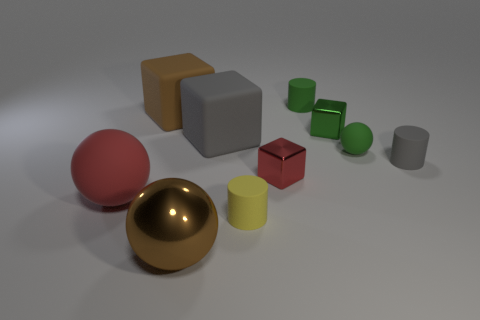Are there an equal number of tiny green shiny things that are right of the tiny red metallic block and tiny green metal things on the left side of the tiny green metal block?
Your answer should be very brief. No. What is the color of the other small thing that is the same shape as the tiny green metallic object?
Your response must be concise. Red. Are there any other things that are the same color as the metal sphere?
Offer a terse response. Yes. What number of matte things are tiny green objects or gray cylinders?
Your answer should be compact. 3. Is the color of the metal ball the same as the tiny rubber sphere?
Your answer should be very brief. No. Are there more small gray rubber cylinders right of the tiny green block than tiny red spheres?
Your answer should be compact. Yes. How many other objects are the same material as the large brown ball?
Keep it short and to the point. 2. What number of large things are red rubber objects or metal balls?
Ensure brevity in your answer.  2. Are the tiny green cube and the red sphere made of the same material?
Provide a succinct answer. No. There is a green shiny block that is right of the brown matte block; what number of red spheres are behind it?
Your answer should be compact. 0. 